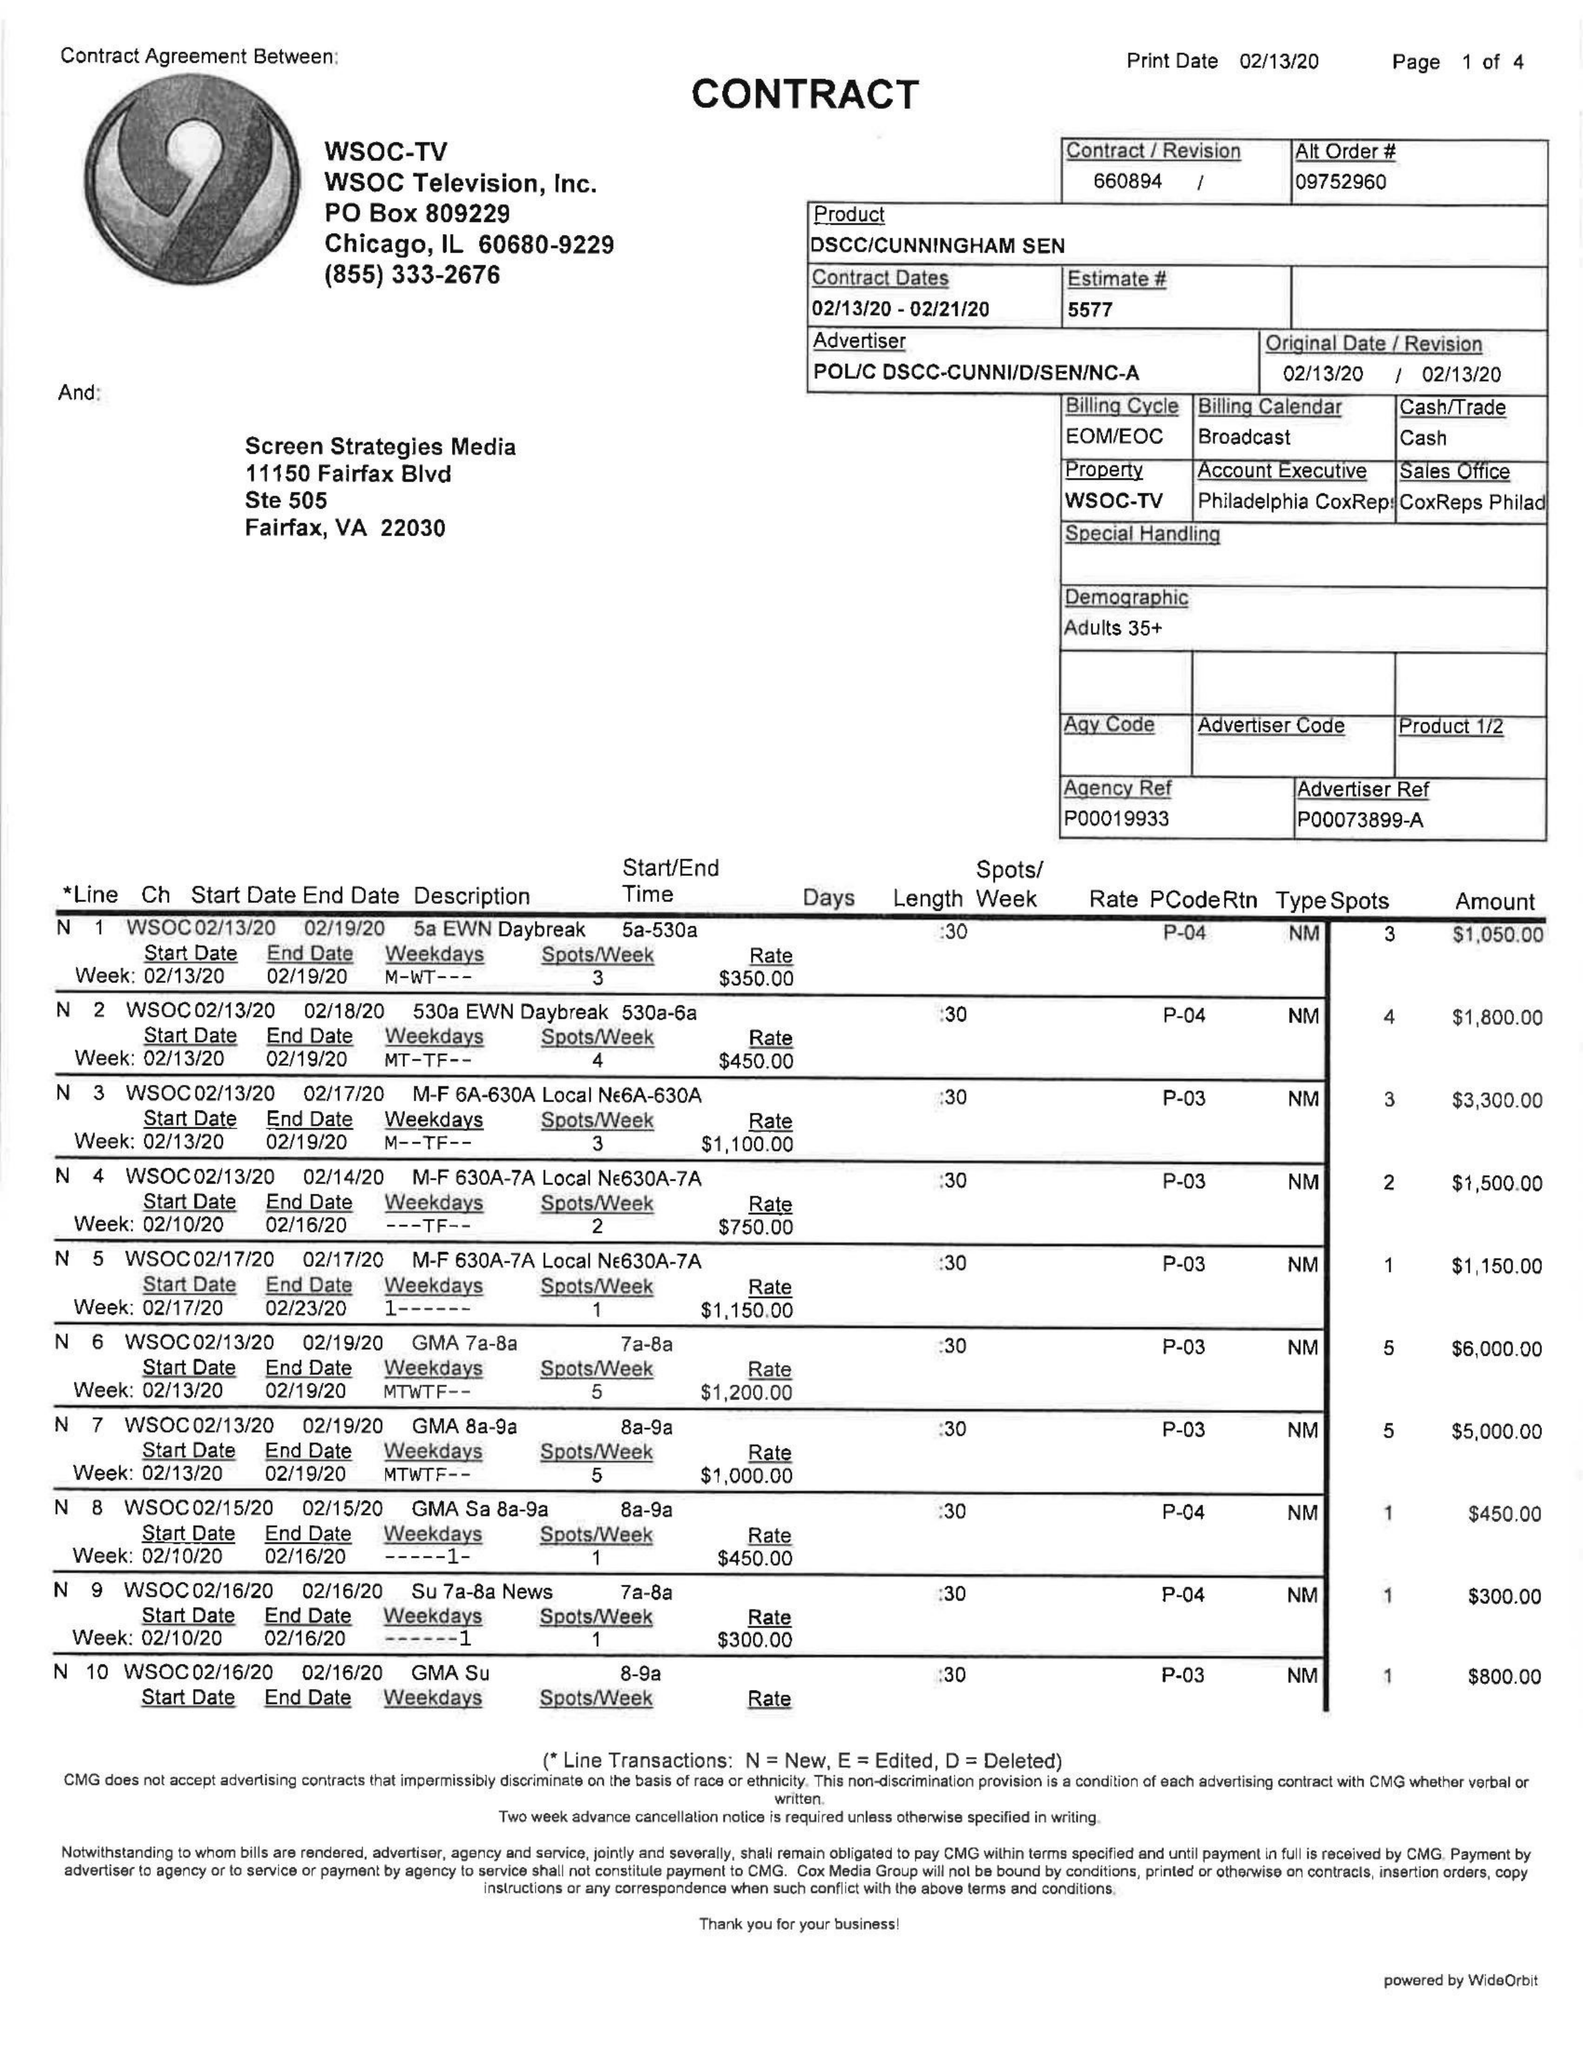What is the value for the advertiser?
Answer the question using a single word or phrase. POL/CDSCC-CUNNI/D/SEN/NC-A 